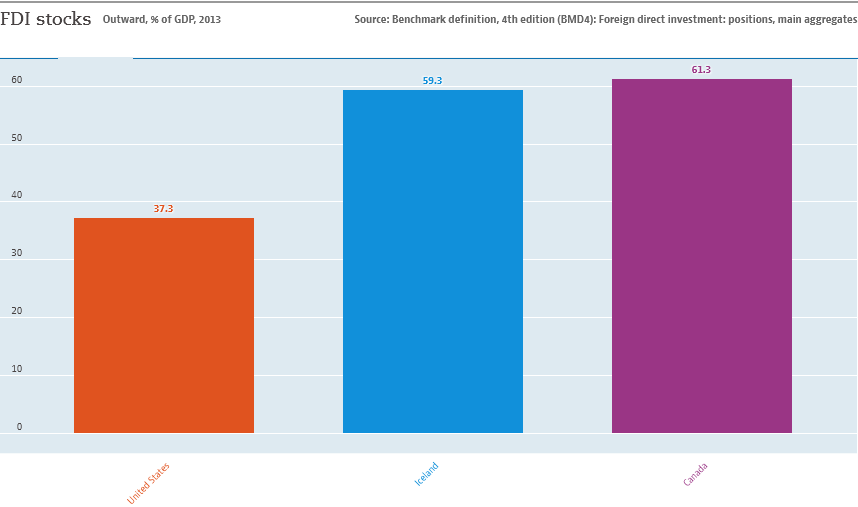Which country has the lowest value in this chart and what does that indicate? The country with the lowest value in the chart is the United States, marked at 37.3%. This lower percentage indicates that while the U.S. might have substantial foreign investment in absolute terms, as a proportion of its very large GDP, this investment comprises a smaller percentage. It could reflect a diverse economy not overly reliant on foreign investments. 